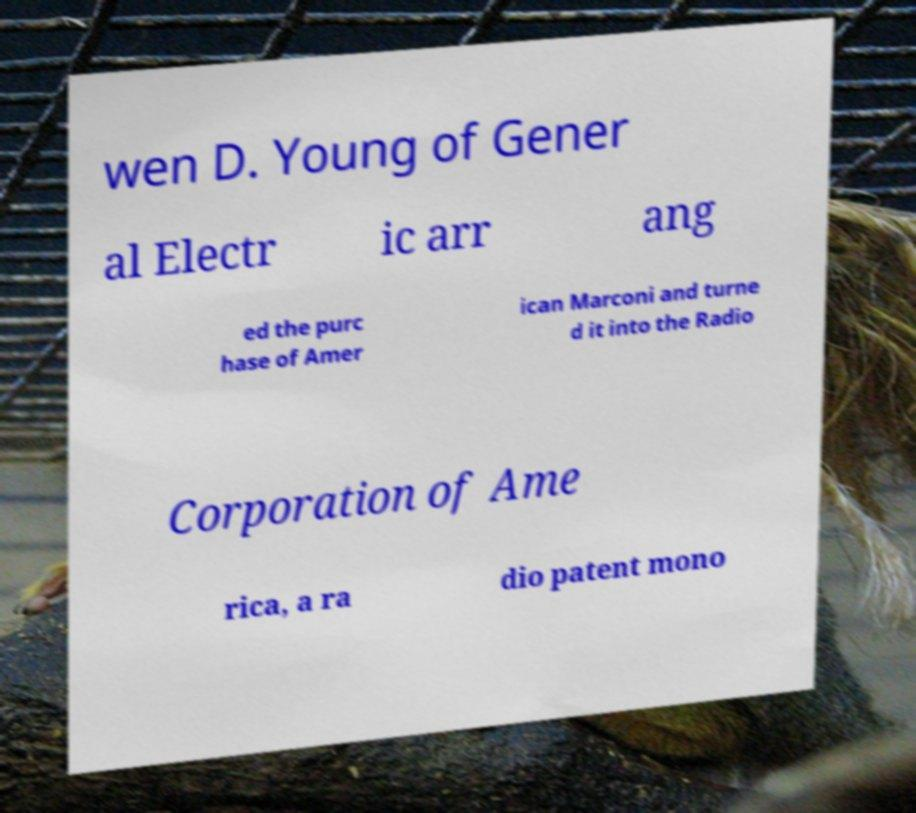Can you accurately transcribe the text from the provided image for me? wen D. Young of Gener al Electr ic arr ang ed the purc hase of Amer ican Marconi and turne d it into the Radio Corporation of Ame rica, a ra dio patent mono 